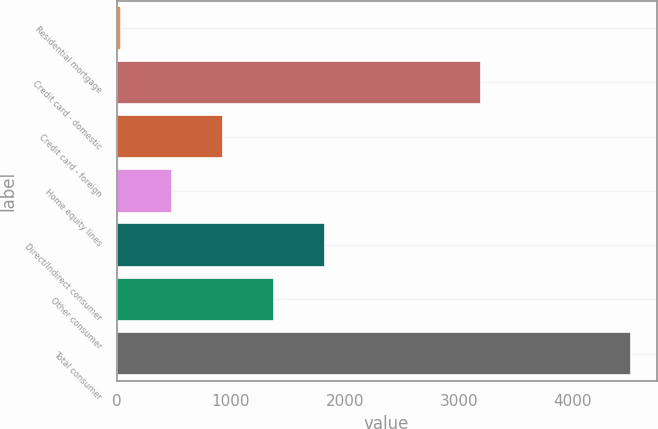<chart> <loc_0><loc_0><loc_500><loc_500><bar_chart><fcel>Residential mortgage<fcel>Credit card - domestic<fcel>Credit card - foreign<fcel>Home equity lines<fcel>Direct/Indirect consumer<fcel>Other consumer<fcel>Total consumer<nl><fcel>39<fcel>3193<fcel>932.6<fcel>485.8<fcel>1826.2<fcel>1379.4<fcel>4507<nl></chart> 